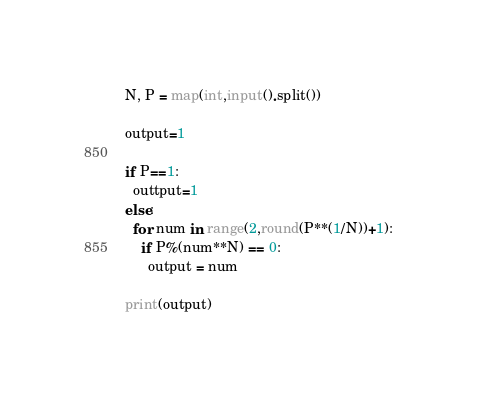Convert code to text. <code><loc_0><loc_0><loc_500><loc_500><_Python_>N, P = map(int,input().split())
 
output=1
 
if P==1:
  outtput=1
else:
  for num in range(2,round(P**(1/N))+1):
    if P%(num**N) == 0:
      output = num
 
print(output)</code> 